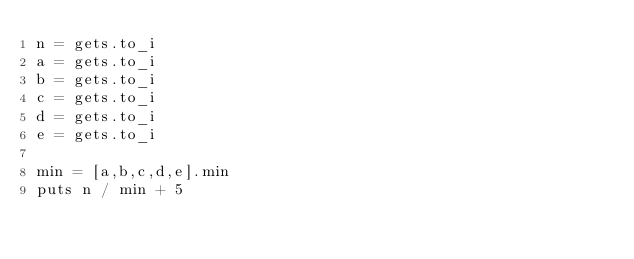Convert code to text. <code><loc_0><loc_0><loc_500><loc_500><_Ruby_>n = gets.to_i
a = gets.to_i
b = gets.to_i
c = gets.to_i
d = gets.to_i
e = gets.to_i

min = [a,b,c,d,e].min
puts n / min + 5
</code> 